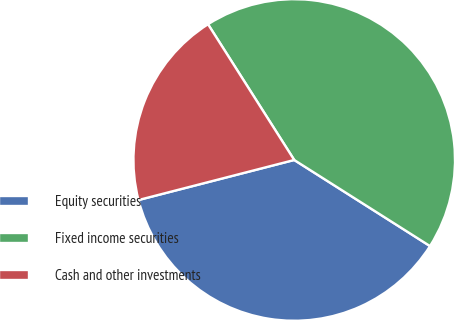Convert chart. <chart><loc_0><loc_0><loc_500><loc_500><pie_chart><fcel>Equity securities<fcel>Fixed income securities<fcel>Cash and other investments<nl><fcel>37.0%<fcel>43.0%<fcel>20.0%<nl></chart> 